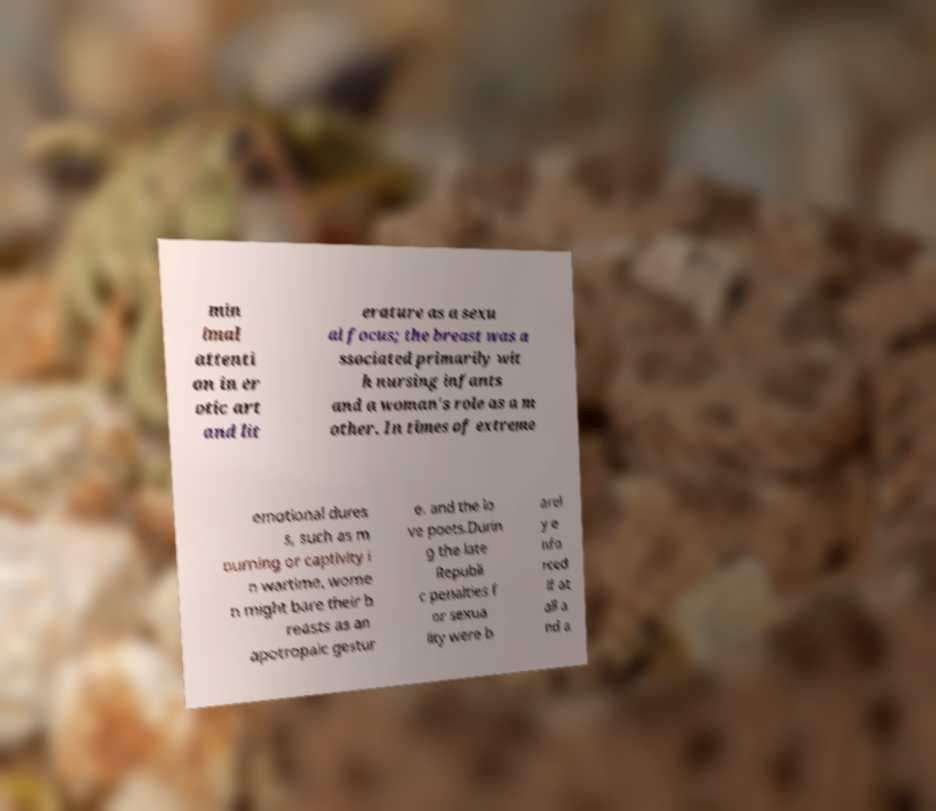Please read and relay the text visible in this image. What does it say? min imal attenti on in er otic art and lit erature as a sexu al focus; the breast was a ssociated primarily wit h nursing infants and a woman's role as a m other. In times of extreme emotional dures s, such as m ourning or captivity i n wartime, wome n might bare their b reasts as an apotropaic gestur e. and the lo ve poets.Durin g the late Republi c penalties f or sexua lity were b arel y e nfo rced if at all a nd a 